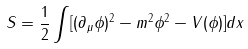Convert formula to latex. <formula><loc_0><loc_0><loc_500><loc_500>S = \frac { 1 } { 2 } \int [ ( \partial _ { \mu } \phi ) ^ { 2 } - m ^ { 2 } \phi ^ { 2 } - V ( \phi ) ] d x</formula> 